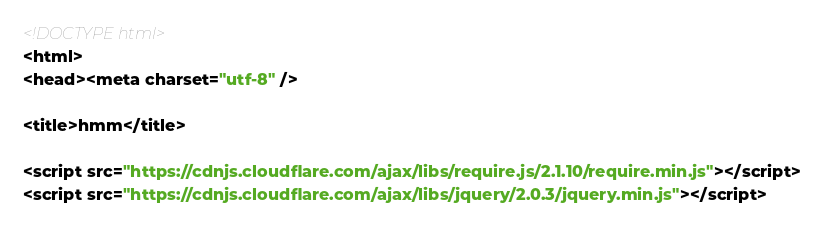Convert code to text. <code><loc_0><loc_0><loc_500><loc_500><_HTML_><!DOCTYPE html>
<html>
<head><meta charset="utf-8" />

<title>hmm</title>

<script src="https://cdnjs.cloudflare.com/ajax/libs/require.js/2.1.10/require.min.js"></script>
<script src="https://cdnjs.cloudflare.com/ajax/libs/jquery/2.0.3/jquery.min.js"></script>


</code> 